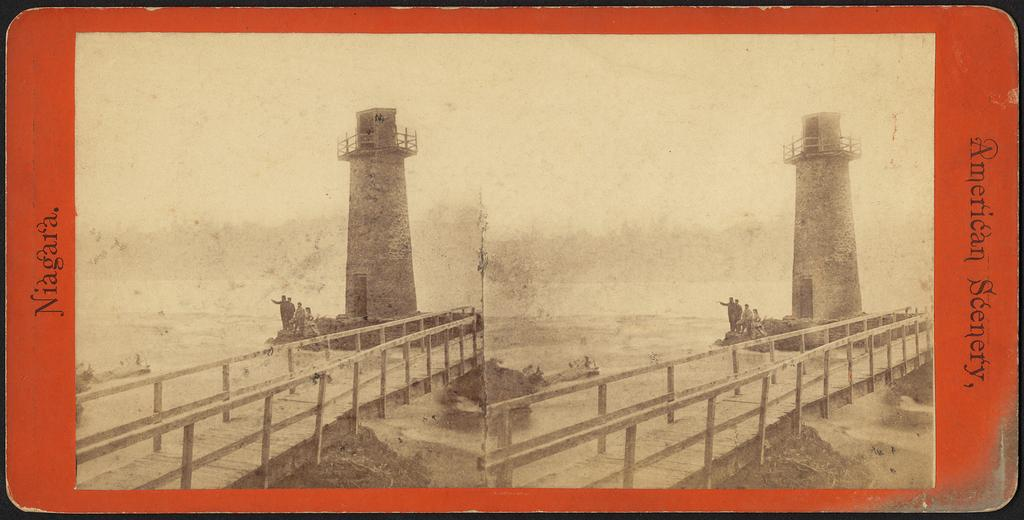<image>
Summarize the visual content of the image. A postcard that shows a light house with the word Niagara on the left. 